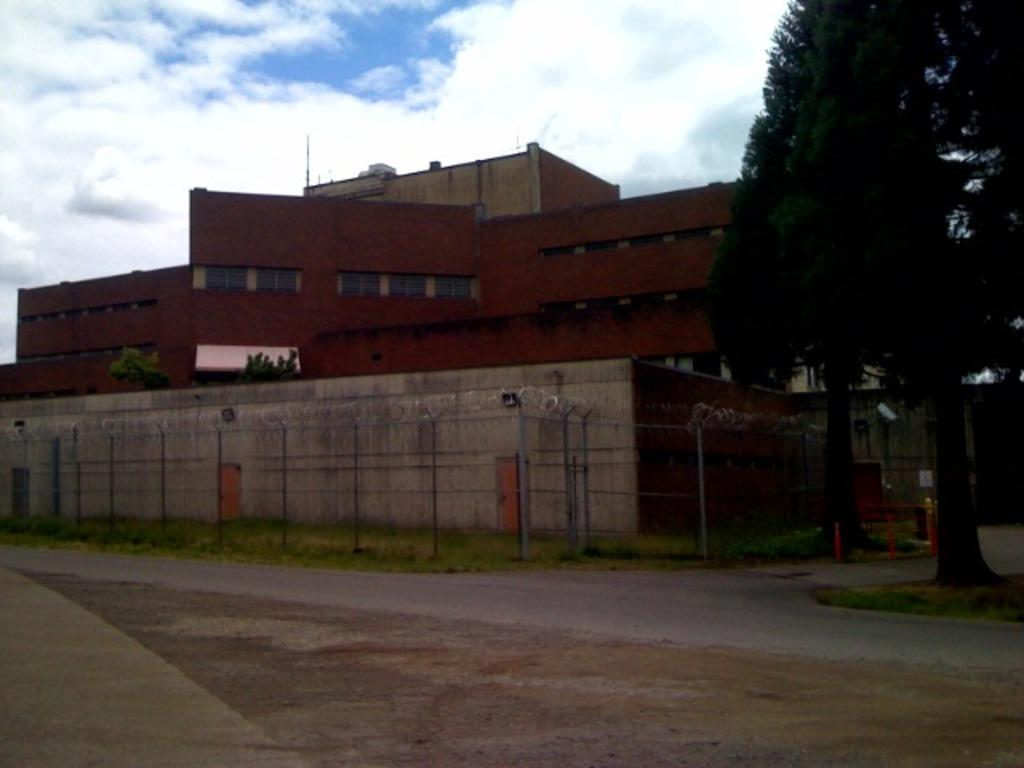What type of plant can be seen in the image? There is a tree in the image. What is the color of the tree? The tree is green. What structure is visible in the background of the image? There is a building in the background of the image. What is the color of the building? The building is maroon. What can be seen in the sky in the image? The sky is blue and white. How many screws are visible on the tree in the image? There are no screws visible on the tree in the image, as trees do not have screws. 